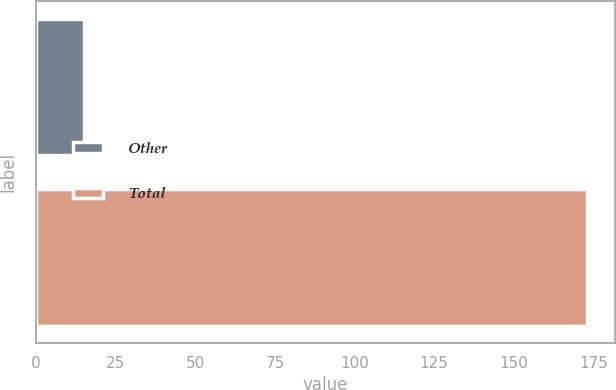Convert chart. <chart><loc_0><loc_0><loc_500><loc_500><bar_chart><fcel>Other<fcel>Total<nl><fcel>15<fcel>173<nl></chart> 